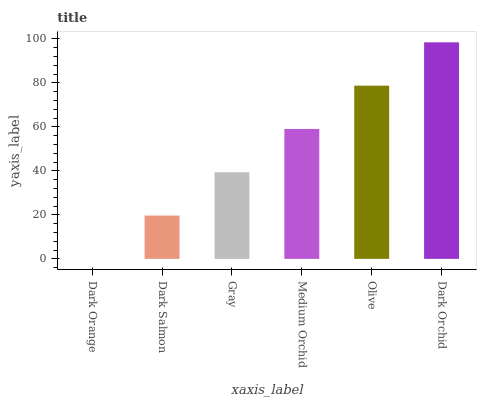Is Dark Orange the minimum?
Answer yes or no. Yes. Is Dark Orchid the maximum?
Answer yes or no. Yes. Is Dark Salmon the minimum?
Answer yes or no. No. Is Dark Salmon the maximum?
Answer yes or no. No. Is Dark Salmon greater than Dark Orange?
Answer yes or no. Yes. Is Dark Orange less than Dark Salmon?
Answer yes or no. Yes. Is Dark Orange greater than Dark Salmon?
Answer yes or no. No. Is Dark Salmon less than Dark Orange?
Answer yes or no. No. Is Medium Orchid the high median?
Answer yes or no. Yes. Is Gray the low median?
Answer yes or no. Yes. Is Gray the high median?
Answer yes or no. No. Is Dark Orange the low median?
Answer yes or no. No. 